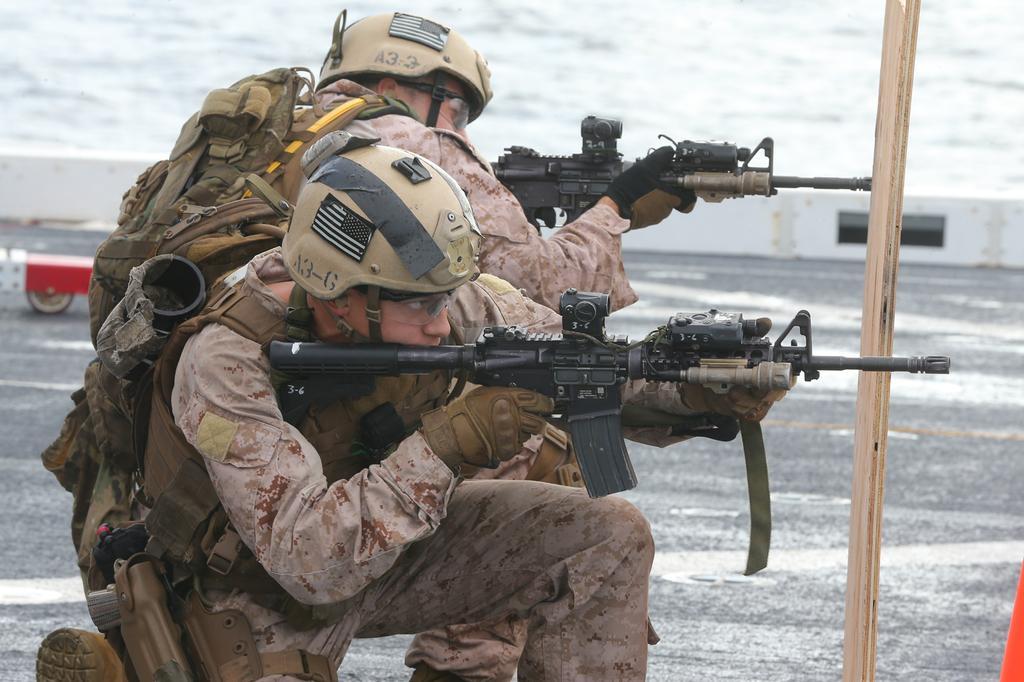Could you give a brief overview of what you see in this image? In this image we can see soldiers, guns and other objects. In the background of the image there is a wall, road and other objects. 